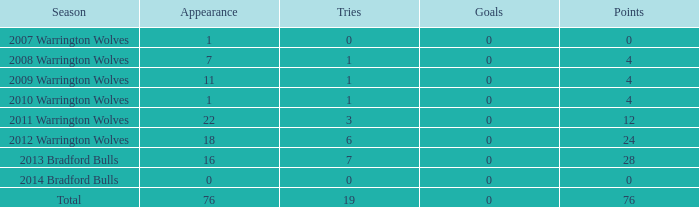How many times is tries 0 and appearance less than 0? 0.0. 